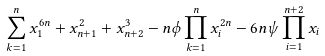Convert formula to latex. <formula><loc_0><loc_0><loc_500><loc_500>\sum _ { k = 1 } ^ { n } x _ { 1 } ^ { 6 n } + x _ { n + 1 } ^ { 2 } + x _ { n + 2 } ^ { 3 } - n \phi \prod _ { k = 1 } ^ { n } x _ { i } ^ { 2 n } - 6 n \psi \prod _ { i = 1 } ^ { n + 2 } x _ { i } \</formula> 